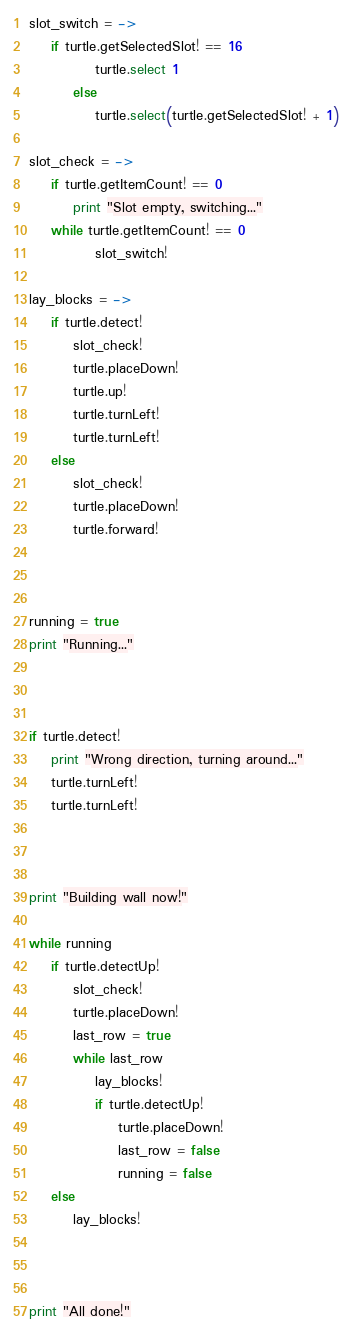Convert code to text. <code><loc_0><loc_0><loc_500><loc_500><_MoonScript_>slot_switch = ->
    if turtle.getSelectedSlot! == 16
            turtle.select 1
        else
            turtle.select(turtle.getSelectedSlot! + 1)

slot_check = ->
    if turtle.getItemCount! == 0
        print "Slot empty, switching..."
    while turtle.getItemCount! == 0
            slot_switch!

lay_blocks = ->
    if turtle.detect!
        slot_check!
        turtle.placeDown!
        turtle.up!
        turtle.turnLeft!
        turtle.turnLeft!
    else
        slot_check!
        turtle.placeDown!
        turtle.forward!
    


running = true
print "Running..."
 


if turtle.detect!
	print "Wrong direction, turning around..."
    turtle.turnLeft!
    turtle.turnLeft!



print "Building wall now!" 

while running
    if turtle.detectUp!
		slot_check!
		turtle.placeDown!
        last_row = true
        while last_row
            lay_blocks!
            if turtle.detectUp!
                turtle.placeDown!
                last_row = false
                running = false
    else
        lay_blocks!



print "All done!"</code> 